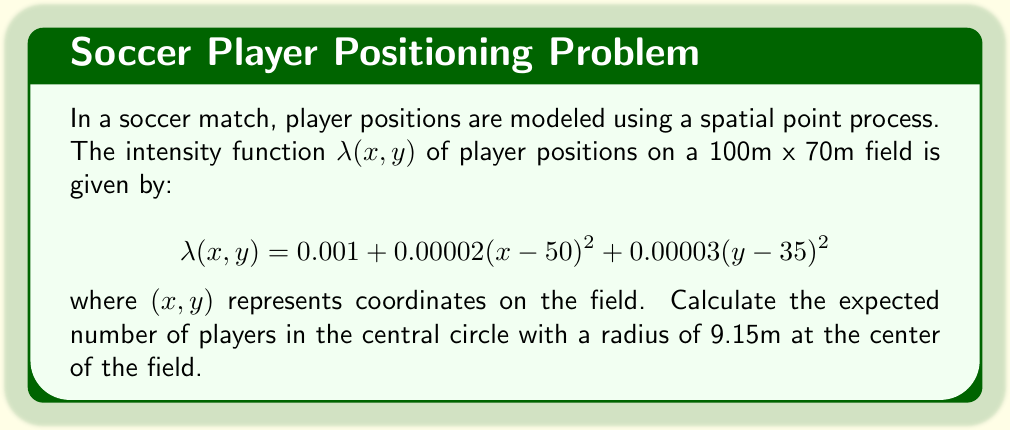Can you answer this question? Let's approach this step-by-step:

1) The expected number of points (players) in a region A is given by the integral of the intensity function over that region:

   $$E[N(A)] = \int\int_A \lambda(x,y) \, dx \, dy$$

2) In this case, A is a circle with radius 9.15m at the center of the field (50,35). We can use polar coordinates to simplify the integration:

   $$E[N(A)] = \int_0^{2\pi} \int_0^{9.15} \lambda(r,\theta) \, r \, dr \, d\theta$$

3) We need to transform $\lambda(x,y)$ to polar coordinates:
   
   $$x = 50 + r\cos\theta$$
   $$y = 35 + r\sin\theta$$

   Substituting these into $\lambda(x,y)$:

   $$\lambda(r,\theta) = 0.001 + 0.00002r^2\cos^2\theta + 0.00003r^2\sin^2\theta$$

4) Now we can set up our integral:

   $$E[N(A)] = \int_0^{2\pi} \int_0^{9.15} (0.001 + 0.00002r^2\cos^2\theta + 0.00003r^2\sin^2\theta) \, r \, dr \, d\theta$$

5) Simplify the integral:

   $$E[N(A)] = 2\pi \int_0^{9.15} (0.001r + 0.00002r^3\frac{1}{2} + 0.00003r^3\frac{1}{2}) \, dr$$

6) Evaluate the integral:

   $$E[N(A)] = 2\pi [0.0005r^2 + 0.0000025r^4]_0^{9.15}$$

7) Compute the final result:

   $$E[N(A)] = 2\pi (0.0005(9.15)^2 + 0.0000025(9.15)^4) \approx 0.2647$$
Answer: 0.2647 players 